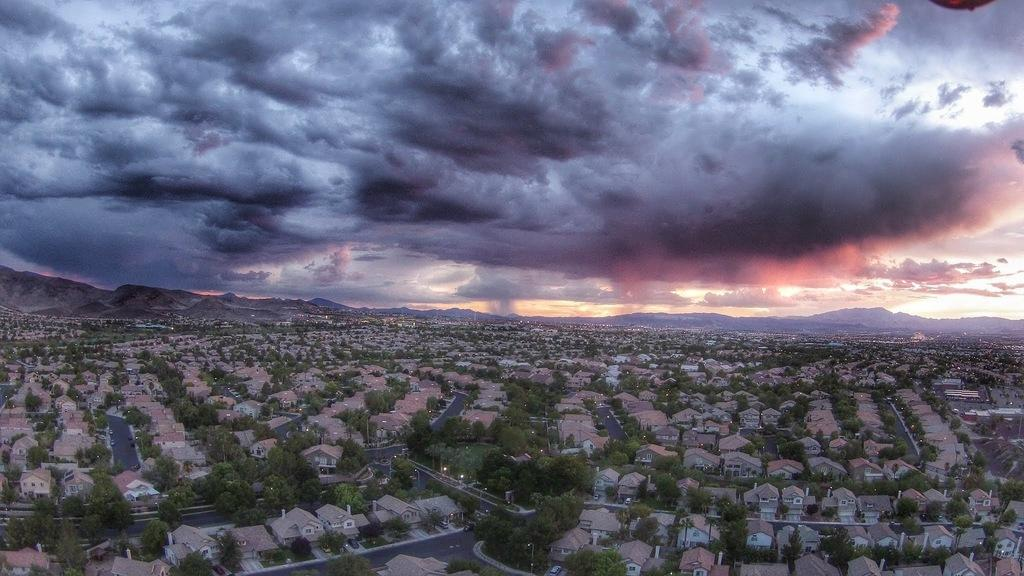What type of structures are present in the image? There are houses in the image. What other natural elements can be seen in the image? There are trees and hills visible in the image. What man-made features are present in the image? There are roads visible in the image. What can be seen in the sky in the background of the image? There are clouds in the sky in the background of the image. Where is the swing located in the image? There is no swing present in the image. What type of stocking is hanging on the trees in the image? There are no stockings hanging on the trees in the image. 